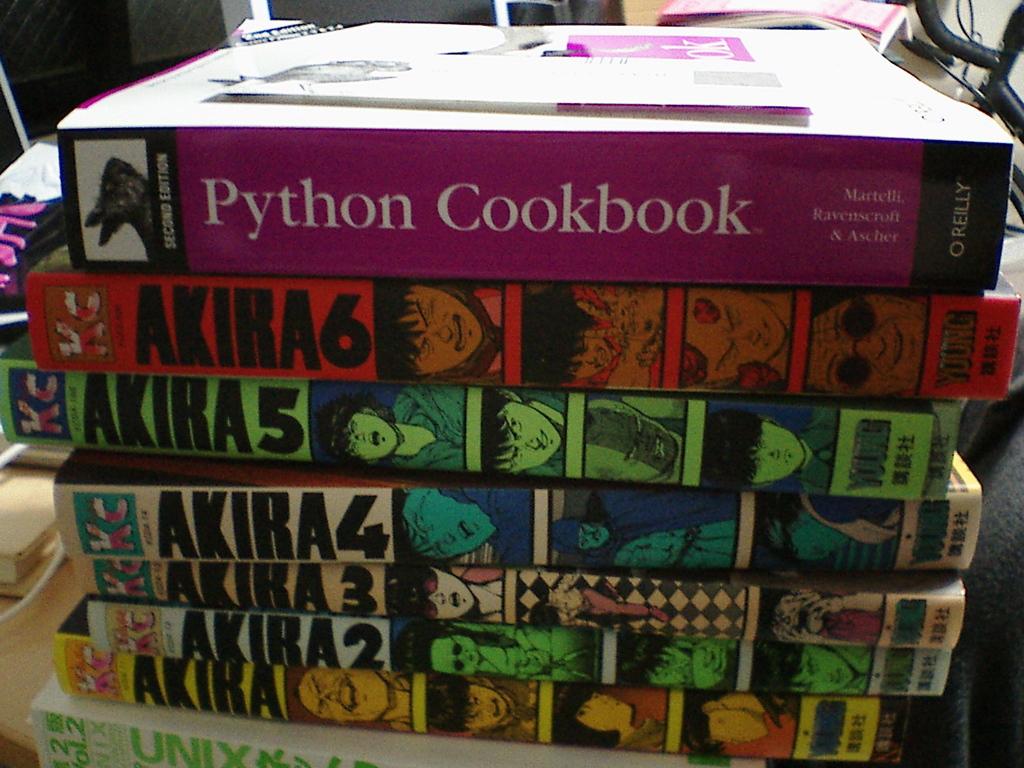How many books are by the title, "akira"?
Your answer should be compact. 6. What is the title of the purple book?
Ensure brevity in your answer.  Python cookbook. 